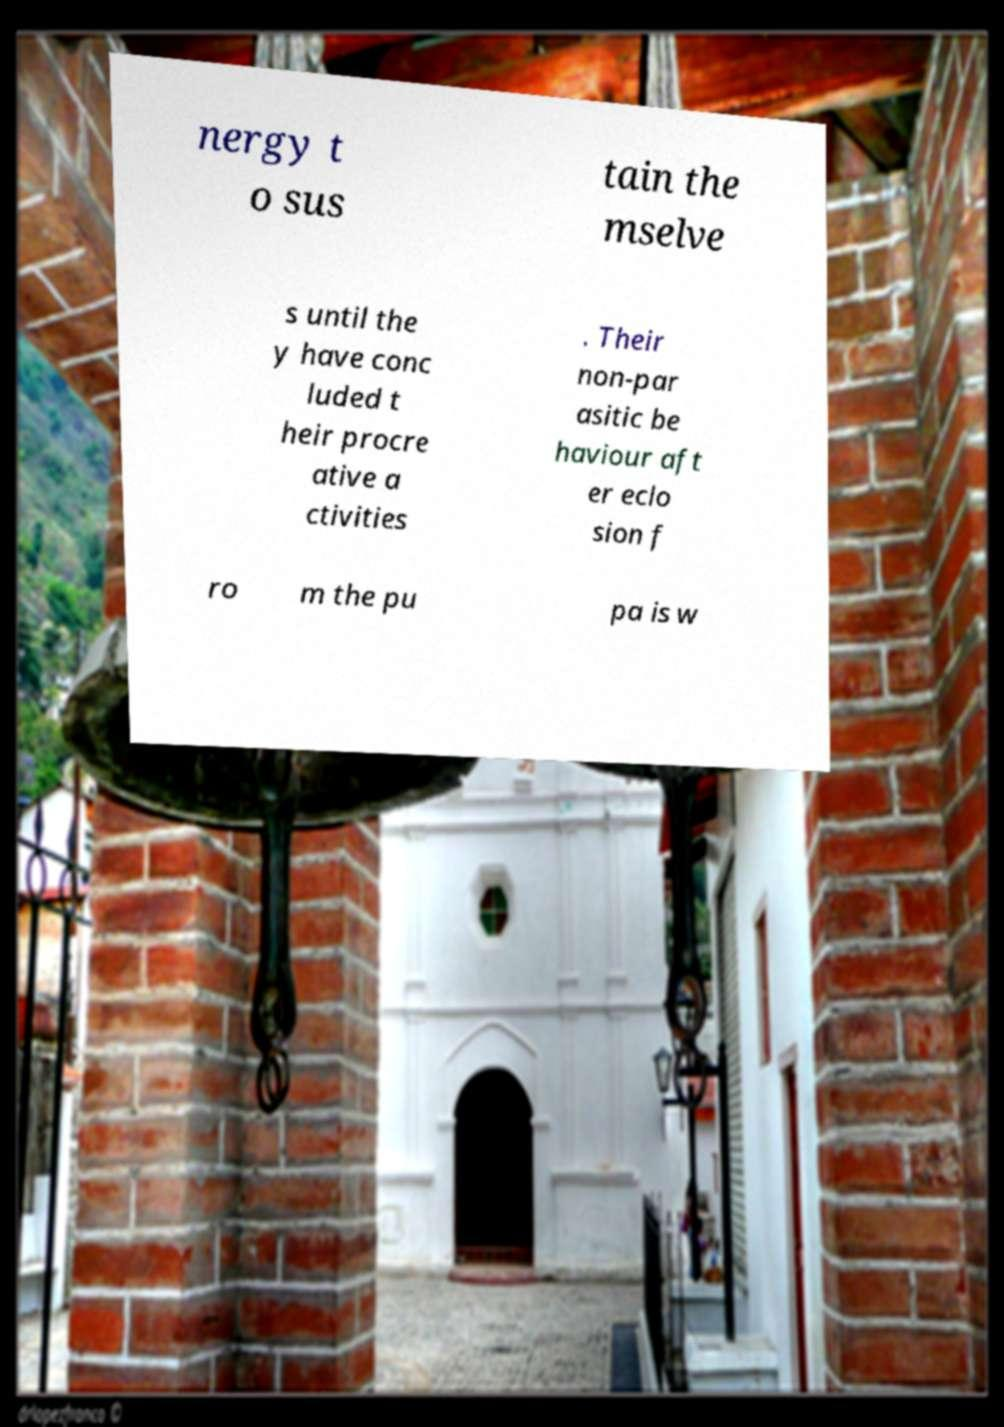Can you accurately transcribe the text from the provided image for me? nergy t o sus tain the mselve s until the y have conc luded t heir procre ative a ctivities . Their non-par asitic be haviour aft er eclo sion f ro m the pu pa is w 